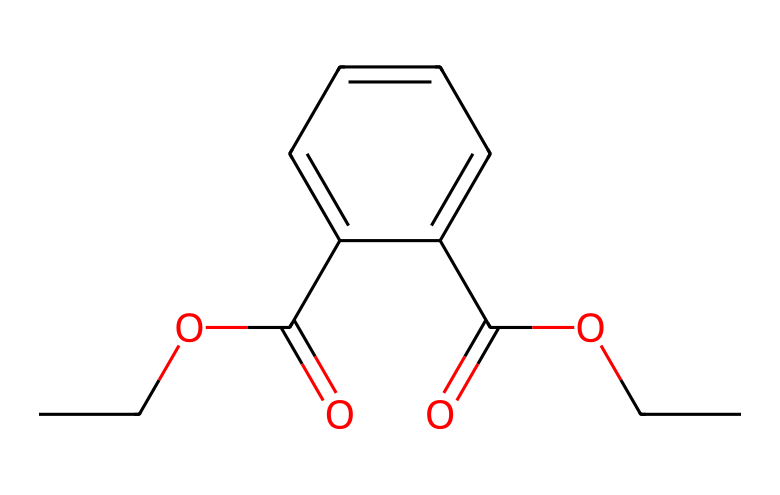What is the molecular formula of diethyl phthalate? The SMILES representation can be analyzed to count the numbers of each type of atom present. In the structure, there are 10 carbon atoms (C), 10 hydrogen atoms (H), and 4 oxygen atoms (O), leading to the molecular formula C10H18O4.
Answer: C10H18O4 How many aromatic rings are present in this compound? By examining the structure in the SMILES, the presence of "c" indicates carbon atoms that are part of an aromatic compound. Here, there is only one aromatic ring (the phenyl ring) evident in the structure.
Answer: 1 What type of functional groups are present in diethyl phthalate? The SMILES representation includes the "C(=O)" which indicates a carbonyl group, and "CCO" indicating an ethyl group with an alcohol bond, making it a di-ester with a carbonyl functional group.
Answer: ester What is the carbon chain length of the alkyl groups in this compound? The ethyl groups (indicated by "CC") have a carbon chain length of 2 each. Since there are two ethyl groups, the overall contribution to the structure from the alkyl chains is 4 carbon atoms (2 from each ethyl).
Answer: 2 What role does diethyl phthalate play in car interior materials? Diethyl phthalate is primarily used as a plasticizer, which means it is added to increase the flexibility and workability of plastics used in car interiors.
Answer: plasticizer Is diethyl phthalate considered a volatile organic compound (VOC)? The structure reveals that diethyl phthalate can easily evaporate into the air at room temperature, which meets the criteria for classification as a VOC.
Answer: yes 